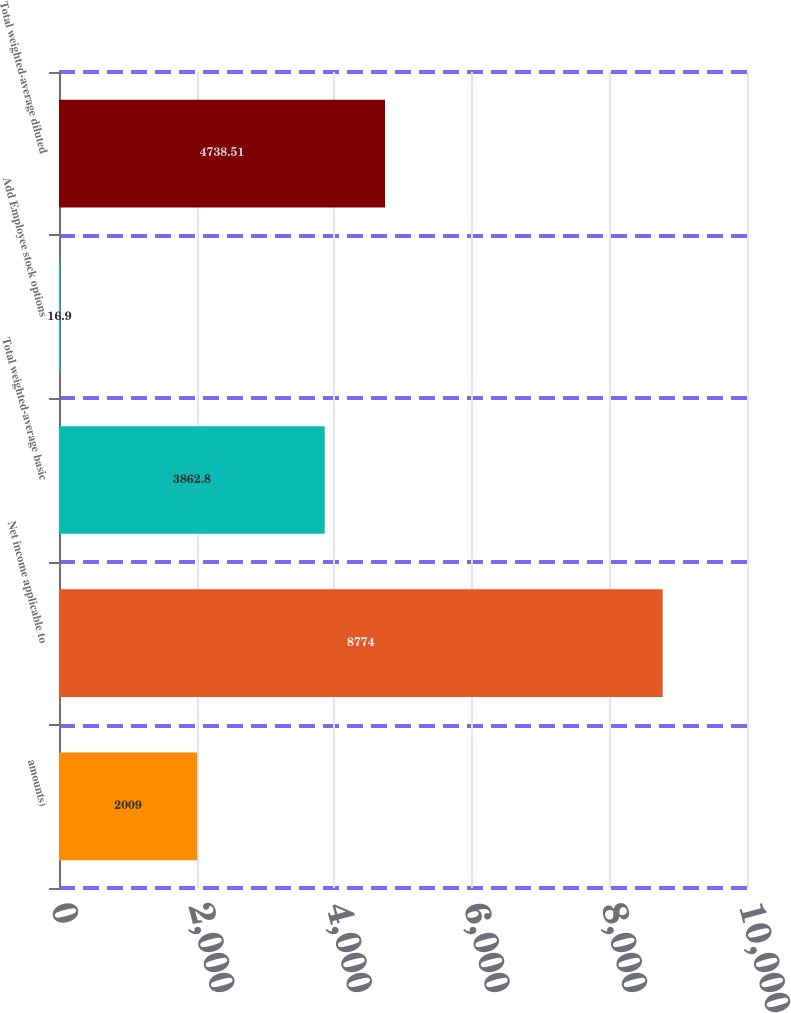Convert chart. <chart><loc_0><loc_0><loc_500><loc_500><bar_chart><fcel>amounts)<fcel>Net income applicable to<fcel>Total weighted-average basic<fcel>Add Employee stock options<fcel>Total weighted-average diluted<nl><fcel>2009<fcel>8774<fcel>3862.8<fcel>16.9<fcel>4738.51<nl></chart> 